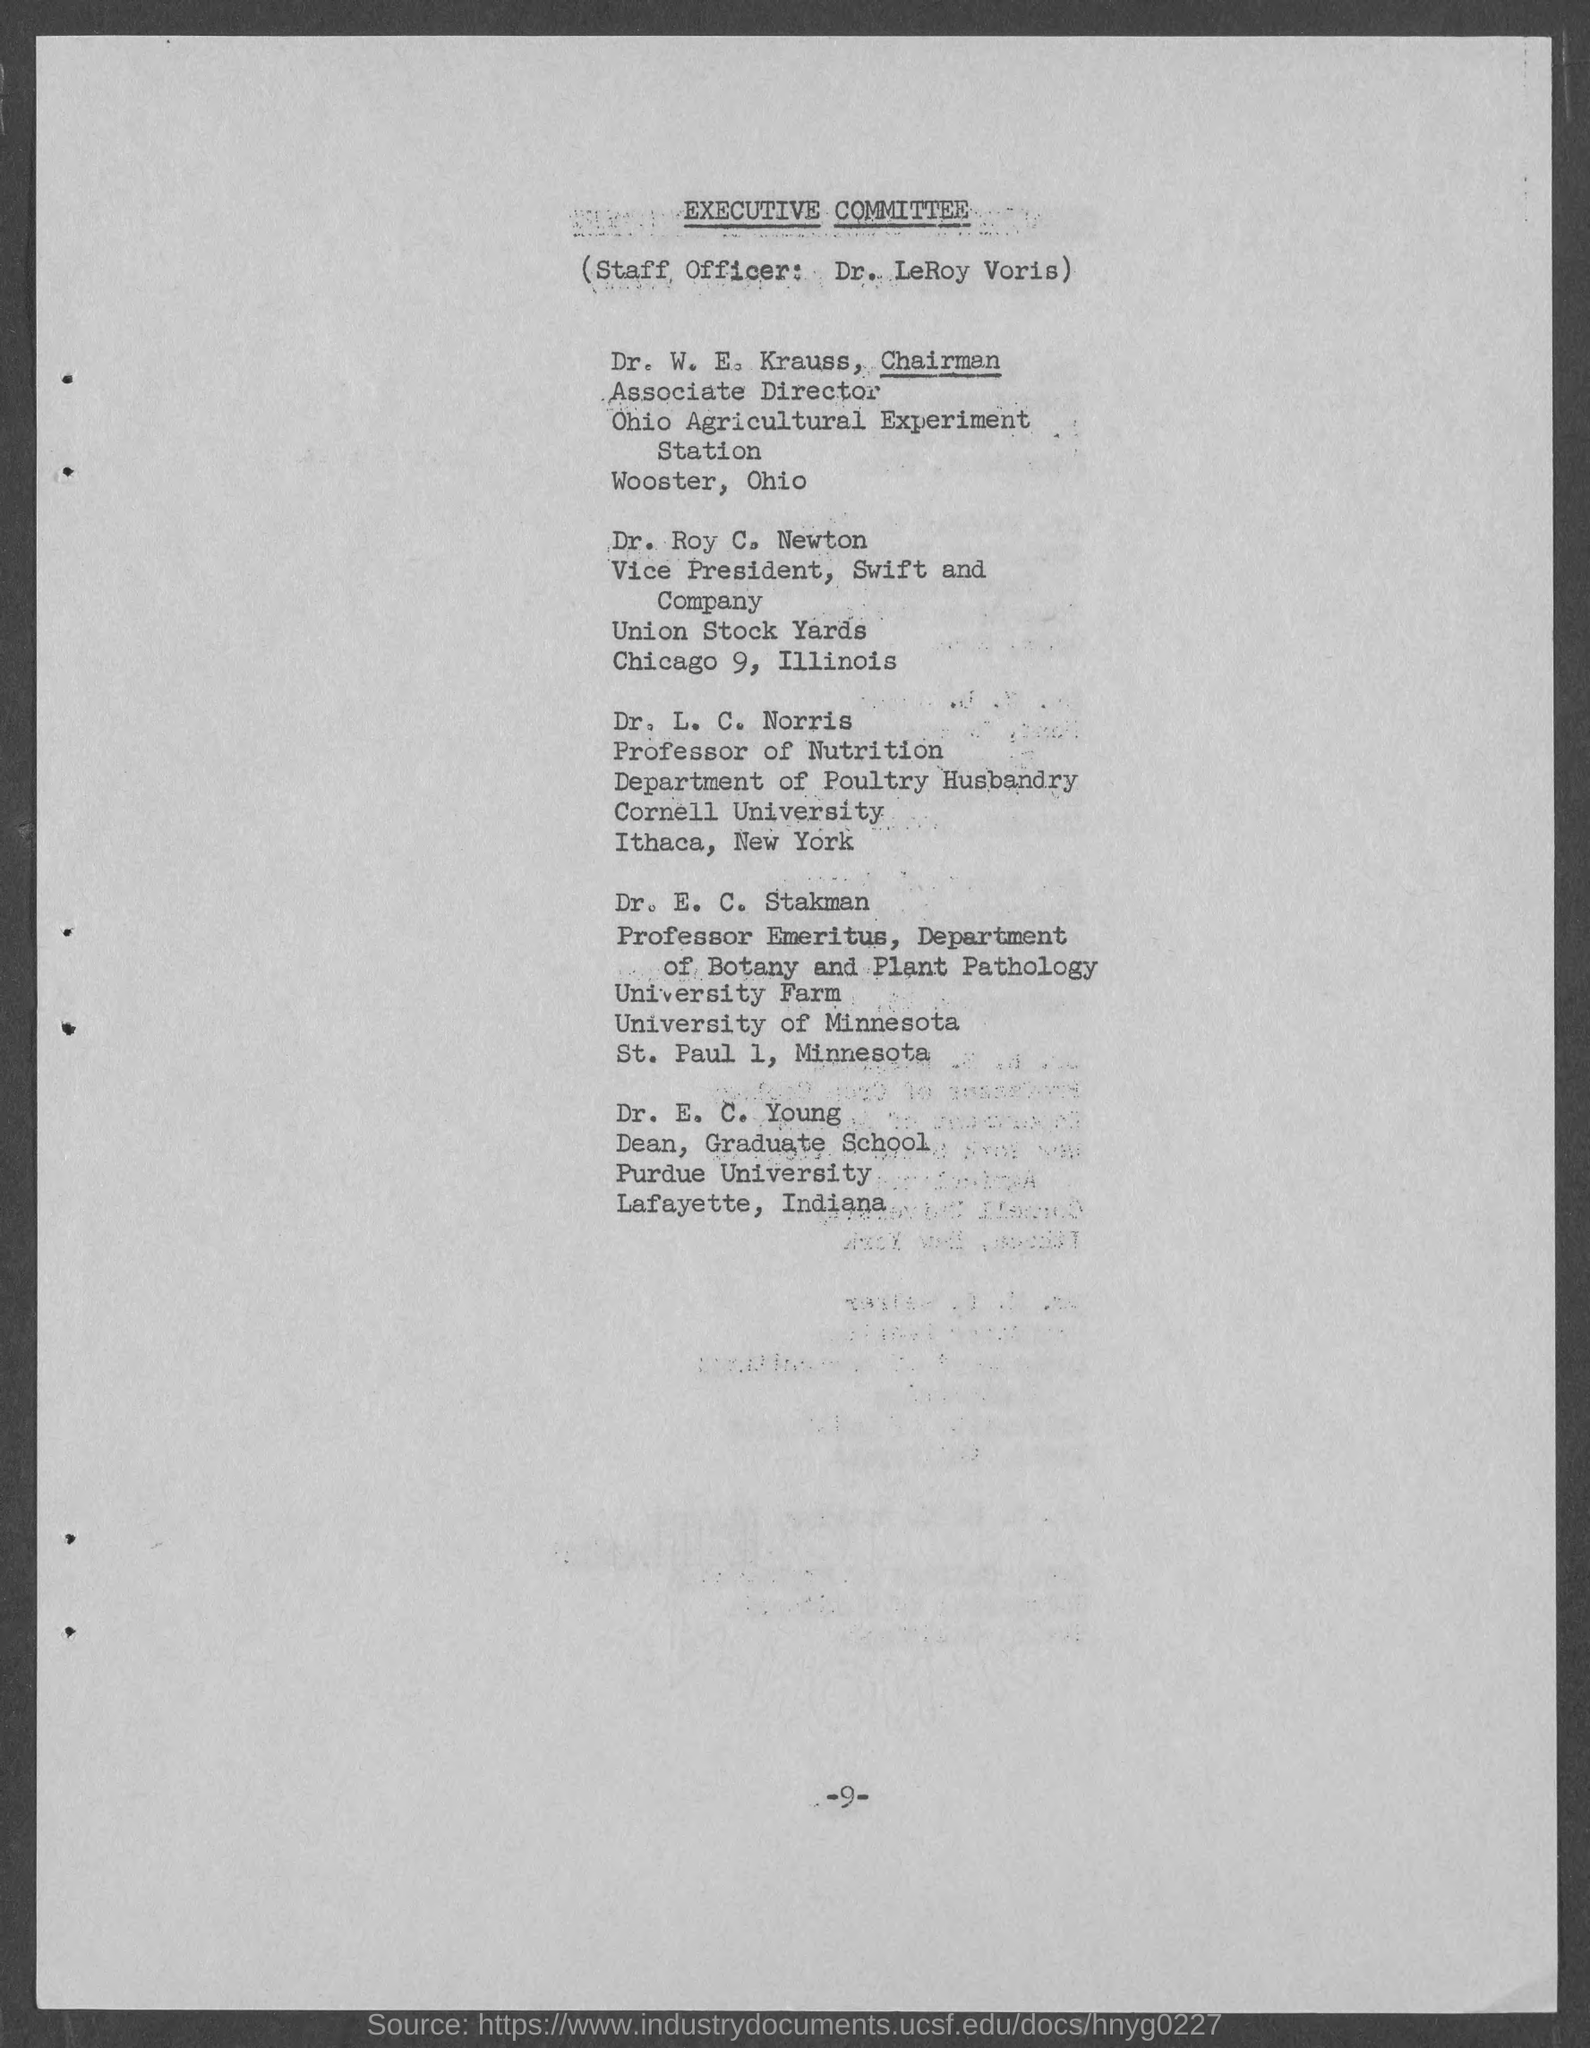Give some essential details in this illustration. The chairman and Associate Director of the Ohio Agriculture ExperimentStation is Dr. W. E. Krauss. The name of the committee is the Executive Committee. Swift and Company has a Vice-president named Dr. Roy C. Newton. Dr. LeRoy Voris is the staff officer. 